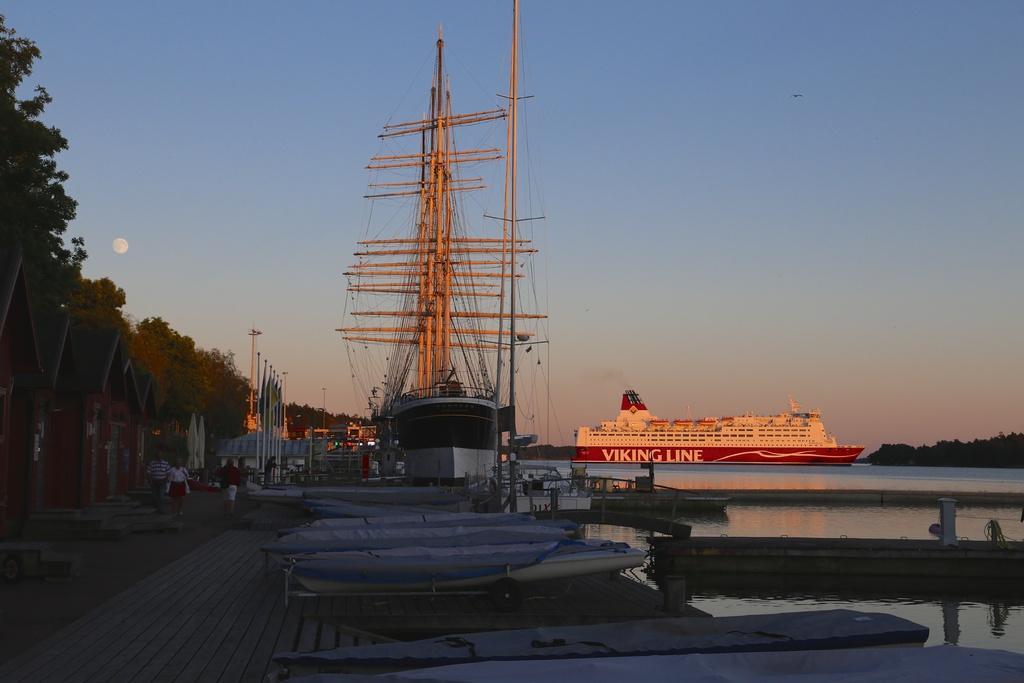Could you give a brief overview of what you see in this image? In this picture we can see some boats in the front, on the right side there is water, on the left side we can see trees and some people, in the background there is a ship, we can see the sky at the top of the picture. 